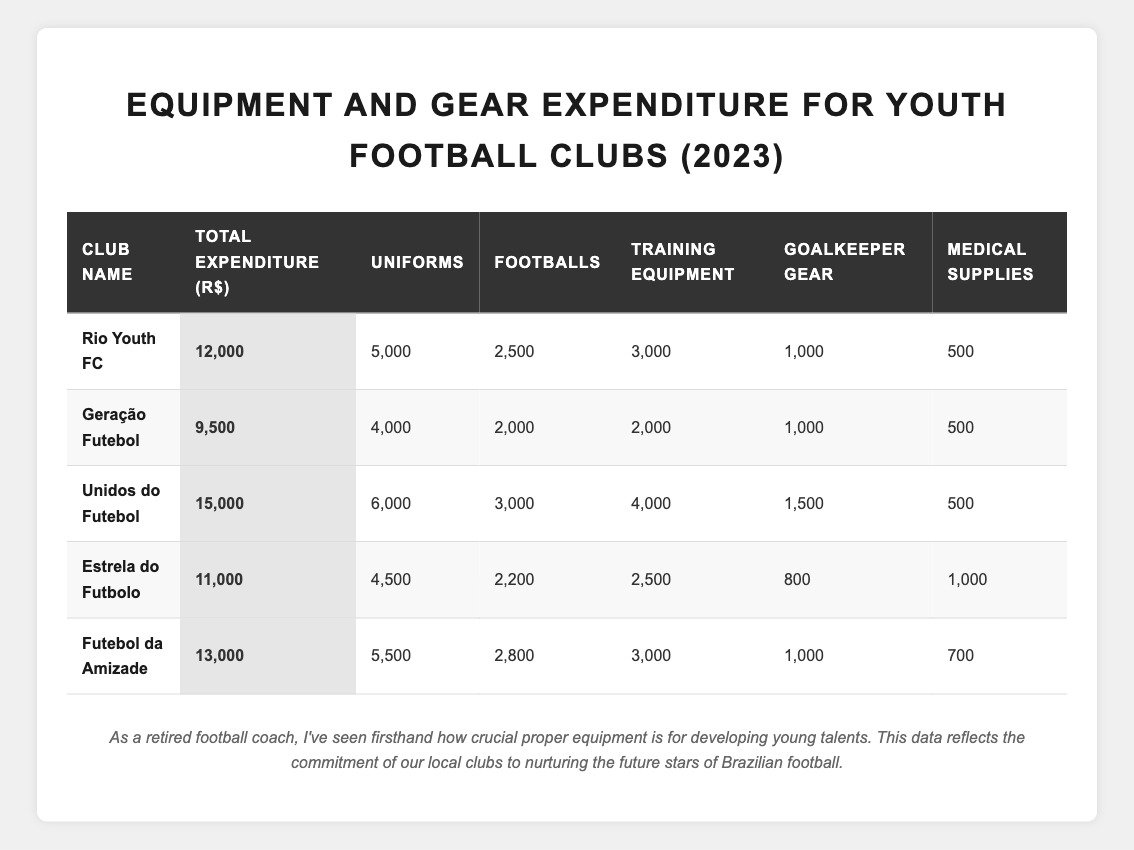What is the total expenditure of "Unidos do Futebol"? The table shows that the total expenditure for "Unidos do Futebol" is listed as 15,000 R$.
Answer: 15,000 R$ Which club spent the most on uniforms? Looking at the "uniforms" column, "Unidos do Futebol" spent 6,000 R$, which is higher than any other club's expenditure on uniforms.
Answer: Unidos do Futebol How much did "Geração Futebol" spend on training equipment? The training equipment expenditure for "Geração Futebol" is shown as 2,000 R$ in the table.
Answer: 2,000 R$ Which club spent a total of 13,000 R$? "Futebol da Amizade" is the only club listed in the table with a total expenditure of 13,000 R$.
Answer: Futebol da Amizade What is the average expenditure on medical supplies by the clubs listed? To find the average, sum the medical supplies expenditures: 500 + 500 + 500 + 1000 + 700 = 3200, divided by 5 clubs gives 3200/5 = 640 R$.
Answer: 640 R$ Did "Rio Youth FC" spend more on goalkeeper gear than "Estrela do Futbolo"? "Rio Youth FC" spent 1,000 R$ on goalkeeper gear, while "Estrela do Futbolo" spent 800 R$. Since 1,000 R$ is greater than 800 R$, the statement is true.
Answer: Yes What is the total amount spent on footballs across all clubs? Sum the expenditures on footballs for each club: 2,500 + 2,000 + 3,000 + 2,200 + 2,800 = 12,500 R$.
Answer: 12,500 R$ Which club spent more on training equipment, "Estrela do Futbolo" or "Futebol da Amizade"? "Estrela do Futbolo" spent 2,500 R$ and "Futebol da Amizade" spent 3,000 R$. Since 3,000 R$ is greater, "Futebol da Amizade" spent more.
Answer: Futebol da Amizade What is the difference in total expenditure between "Unidos do Futebol" and "Geração Futebol"? The difference is calculated by subtracting Geração Futebol's expenditure (9,500 R$) from Unidos do Futebol's (15,000 R$): 15,000 - 9,500 = 5,500 R$.
Answer: 5,500 R$ Which club has the least total expenditure, and what is the amount? The table shows that "Geração Futebol" has the least total expenditure at 9,500 R$.
Answer: Geração Futebol, 9,500 R$ 